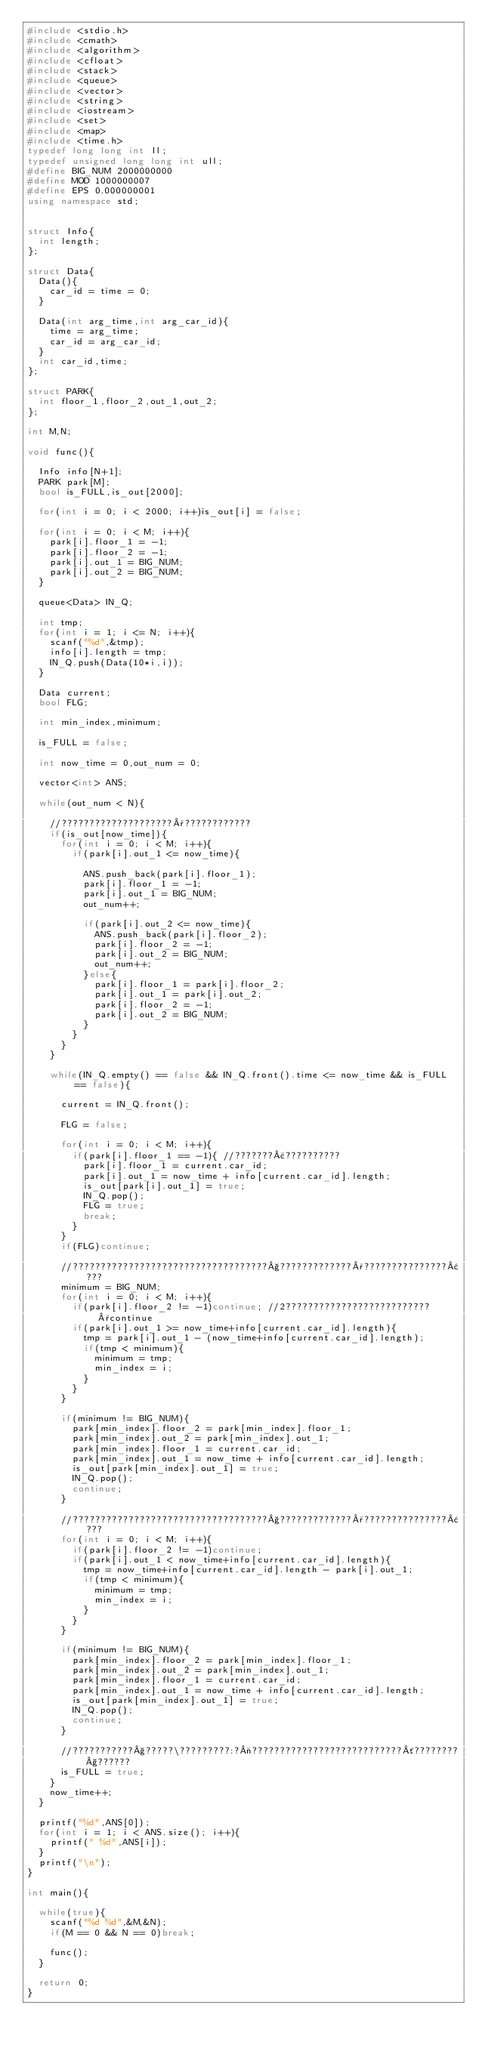Convert code to text. <code><loc_0><loc_0><loc_500><loc_500><_C++_>#include <stdio.h>
#include <cmath>
#include <algorithm>
#include <cfloat>
#include <stack>
#include <queue>
#include <vector>
#include <string>
#include <iostream>
#include <set>
#include <map>
#include <time.h>
typedef long long int ll;
typedef unsigned long long int ull;
#define BIG_NUM 2000000000
#define MOD 1000000007
#define EPS 0.000000001
using namespace std;


struct Info{
	int length;
};

struct Data{
	Data(){
		car_id = time = 0;
	}

	Data(int arg_time,int arg_car_id){
		time = arg_time;
		car_id = arg_car_id;
	}
	int car_id,time;
};

struct PARK{
	int floor_1,floor_2,out_1,out_2;
};

int M,N;

void func(){

	Info info[N+1];
	PARK park[M];
	bool is_FULL,is_out[2000];

	for(int i = 0; i < 2000; i++)is_out[i] = false;

	for(int i = 0; i < M; i++){
		park[i].floor_1 = -1;
		park[i].floor_2 = -1;
		park[i].out_1 = BIG_NUM;
		park[i].out_2 = BIG_NUM;
	}

	queue<Data> IN_Q;

	int tmp;
	for(int i = 1; i <= N; i++){
		scanf("%d",&tmp);
		info[i].length = tmp;
		IN_Q.push(Data(10*i,i));
	}

	Data current;
	bool FLG;

	int min_index,minimum;

	is_FULL = false;

	int now_time = 0,out_num = 0;

	vector<int> ANS;

	while(out_num < N){

		//????????????????????°????????????
		if(is_out[now_time]){
			for(int i = 0; i < M; i++){
				if(park[i].out_1 <= now_time){

					ANS.push_back(park[i].floor_1);
					park[i].floor_1 = -1;
					park[i].out_1 = BIG_NUM;
					out_num++;

					if(park[i].out_2 <= now_time){
						ANS.push_back(park[i].floor_2);
						park[i].floor_2 = -1;
						park[i].out_2 = BIG_NUM;
						out_num++;
					}else{
						park[i].floor_1 = park[i].floor_2;
						park[i].out_1 = park[i].out_2;
						park[i].floor_2 = -1;
						park[i].out_2 = BIG_NUM;
					}
				}
			}
		}

		while(IN_Q.empty() == false && IN_Q.front().time <= now_time && is_FULL == false){

			current = IN_Q.front();

			FLG = false;

			for(int i = 0; i < M; i++){
				if(park[i].floor_1 == -1){ //???????£??????????
					park[i].floor_1 = current.car_id;
					park[i].out_1 = now_time + info[current.car_id].length;
					is_out[park[i].out_1] = true;
					IN_Q.pop();
					FLG = true;
					break;
				}
			}
			if(FLG)continue;

			//???????????????????????????????????§?????????????°???????????????¢???
			minimum = BIG_NUM;
			for(int i = 0; i < M; i++){
				if(park[i].floor_2 != -1)continue; //2??????????????????????????°continue
				if(park[i].out_1 >= now_time+info[current.car_id].length){
					tmp = park[i].out_1 - (now_time+info[current.car_id].length);
					if(tmp < minimum){
						minimum = tmp;
						min_index = i;
					}
				}
			}

			if(minimum != BIG_NUM){
				park[min_index].floor_2 = park[min_index].floor_1;
				park[min_index].out_2 = park[min_index].out_1;
				park[min_index].floor_1 = current.car_id;
				park[min_index].out_1 = now_time + info[current.car_id].length;
				is_out[park[min_index].out_1] = true;
				IN_Q.pop();
				continue;
			}

			//???????????????????????????????????§?????????????°???????????????¢???
			for(int i = 0; i < M; i++){
				if(park[i].floor_2 != -1)continue;
				if(park[i].out_1 < now_time+info[current.car_id].length){
					tmp = now_time+info[current.car_id].length - park[i].out_1;
					if(tmp < minimum){
						minimum = tmp;
						min_index = i;
					}
				}
			}

			if(minimum != BIG_NUM){
				park[min_index].floor_2 = park[min_index].floor_1;
				park[min_index].out_2 = park[min_index].out_1;
				park[min_index].floor_1 = current.car_id;
				park[min_index].out_1 = now_time + info[current.car_id].length;
				is_out[park[min_index].out_1] = true;
				IN_Q.pop();
				continue;
			}

			//???????????§?????\?????????:?¬???????????????????????????´????????§??????
			is_FULL = true;
		}
		now_time++;
	}

	printf("%d",ANS[0]);
	for(int i = 1; i < ANS.size(); i++){
		printf(" %d",ANS[i]);
	}
	printf("\n");
}

int main(){

	while(true){
		scanf("%d %d",&M,&N);
		if(M == 0 && N == 0)break;

		func();
	}

	return 0;
}</code> 